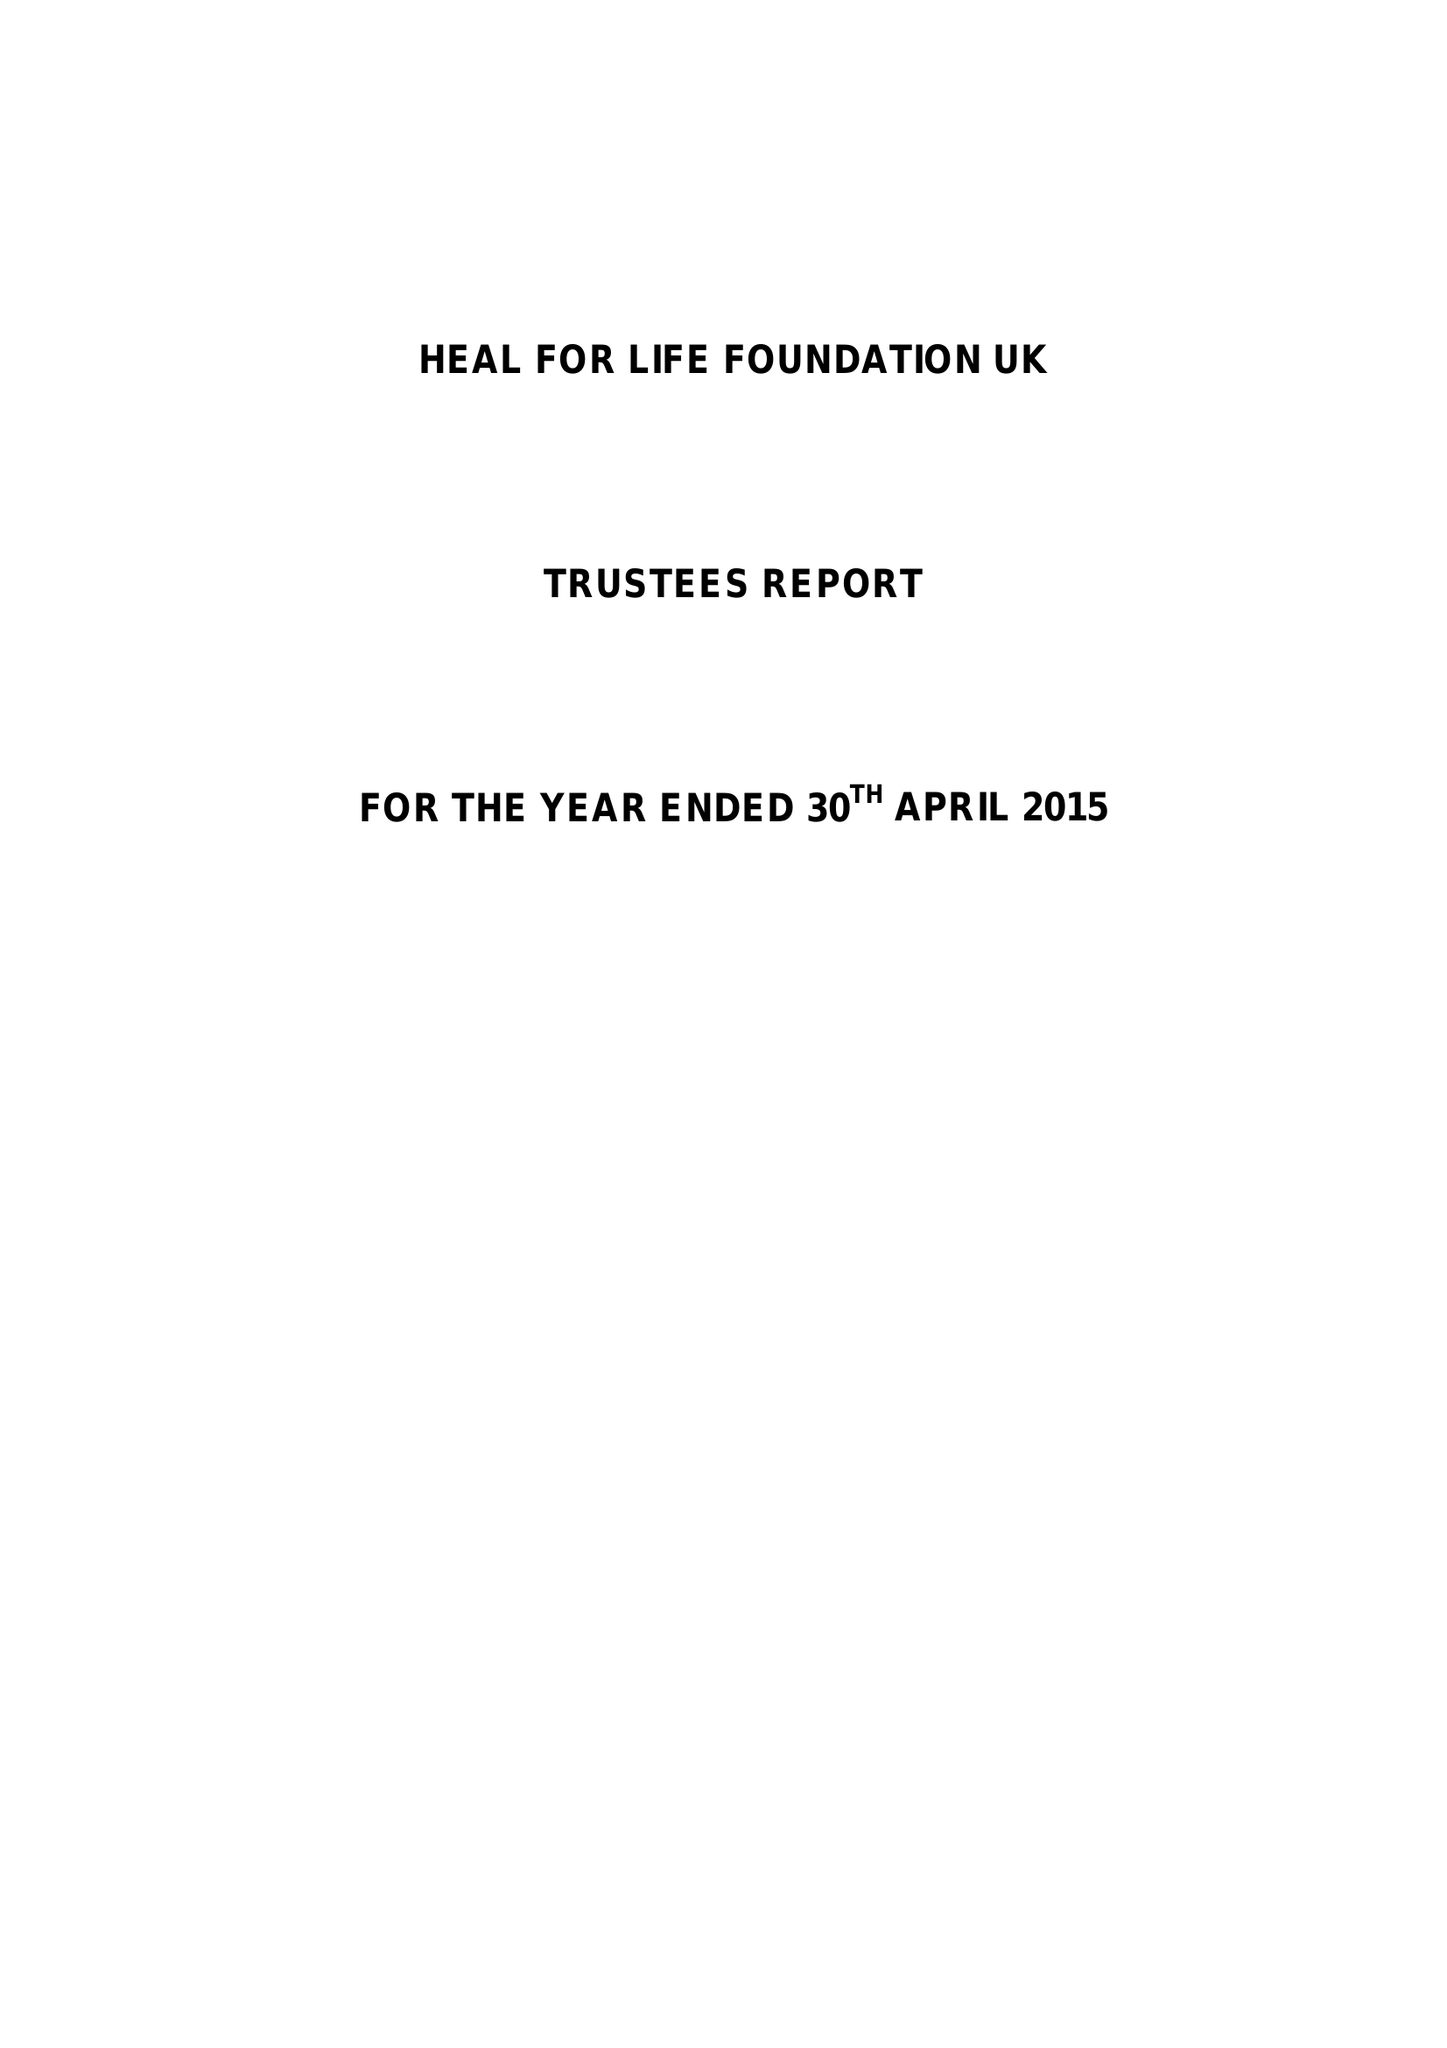What is the value for the spending_annually_in_british_pounds?
Answer the question using a single word or phrase. 9441.00 